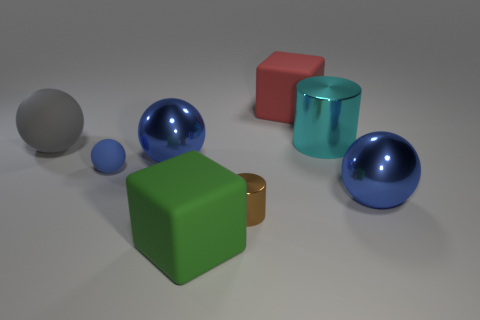Do the gray matte sphere and the brown cylinder have the same size?
Your answer should be compact. No. Are there an equal number of big balls on the right side of the cyan cylinder and gray matte balls?
Make the answer very short. Yes. Are there any small metallic things that are right of the big sphere on the right side of the red cube?
Your answer should be compact. No. What is the size of the matte sphere in front of the large sphere left of the metal ball that is left of the cyan thing?
Make the answer very short. Small. There is a blue sphere to the right of the large cube that is right of the tiny shiny thing; what is it made of?
Offer a very short reply. Metal. Is there a blue metal thing that has the same shape as the cyan metallic thing?
Your answer should be compact. No. What shape is the large red object?
Make the answer very short. Cube. The sphere that is in front of the tiny matte thing behind the ball that is in front of the tiny rubber ball is made of what material?
Give a very brief answer. Metal. Are there more cyan things in front of the big matte ball than gray objects?
Ensure brevity in your answer.  No. There is a cylinder that is the same size as the red matte cube; what is its material?
Provide a succinct answer. Metal. 